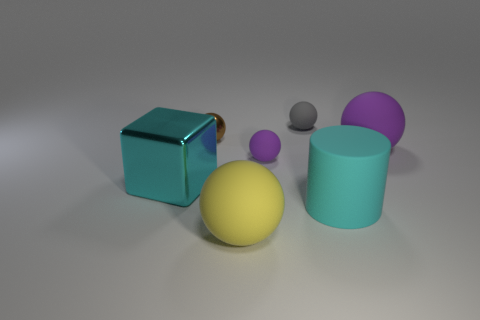Add 3 big cyan rubber things. How many objects exist? 10 Subtract all cylinders. How many objects are left? 6 Subtract all gray spheres. How many spheres are left? 4 Subtract all tiny matte spheres. How many spheres are left? 3 Subtract 0 green blocks. How many objects are left? 7 Subtract 1 spheres. How many spheres are left? 4 Subtract all blue spheres. Subtract all gray blocks. How many spheres are left? 5 Subtract all gray cylinders. How many red balls are left? 0 Subtract all small green matte balls. Subtract all cyan matte cylinders. How many objects are left? 6 Add 5 small purple rubber spheres. How many small purple rubber spheres are left? 6 